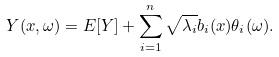<formula> <loc_0><loc_0><loc_500><loc_500>Y ( x , \omega ) = E [ Y ] + \sum _ { i = 1 } ^ { n } \sqrt { \lambda _ { i } } b _ { i } ( x ) \theta _ { i } ( \omega ) .</formula> 